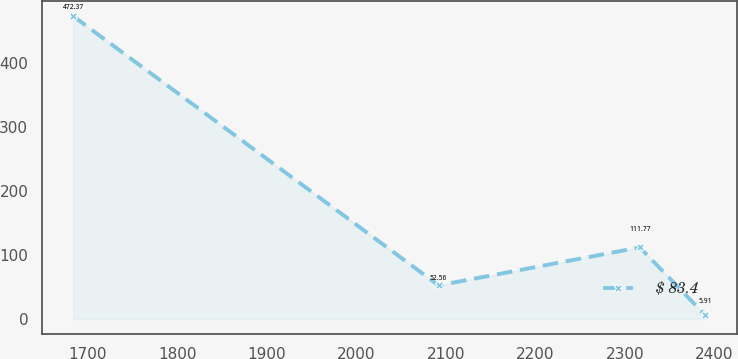Convert chart to OTSL. <chart><loc_0><loc_0><loc_500><loc_500><line_chart><ecel><fcel>$ 83.4<nl><fcel>1683.52<fcel>472.37<nl><fcel>2091.91<fcel>52.56<nl><fcel>2316.67<fcel>111.77<nl><fcel>2389.92<fcel>5.91<nl></chart> 